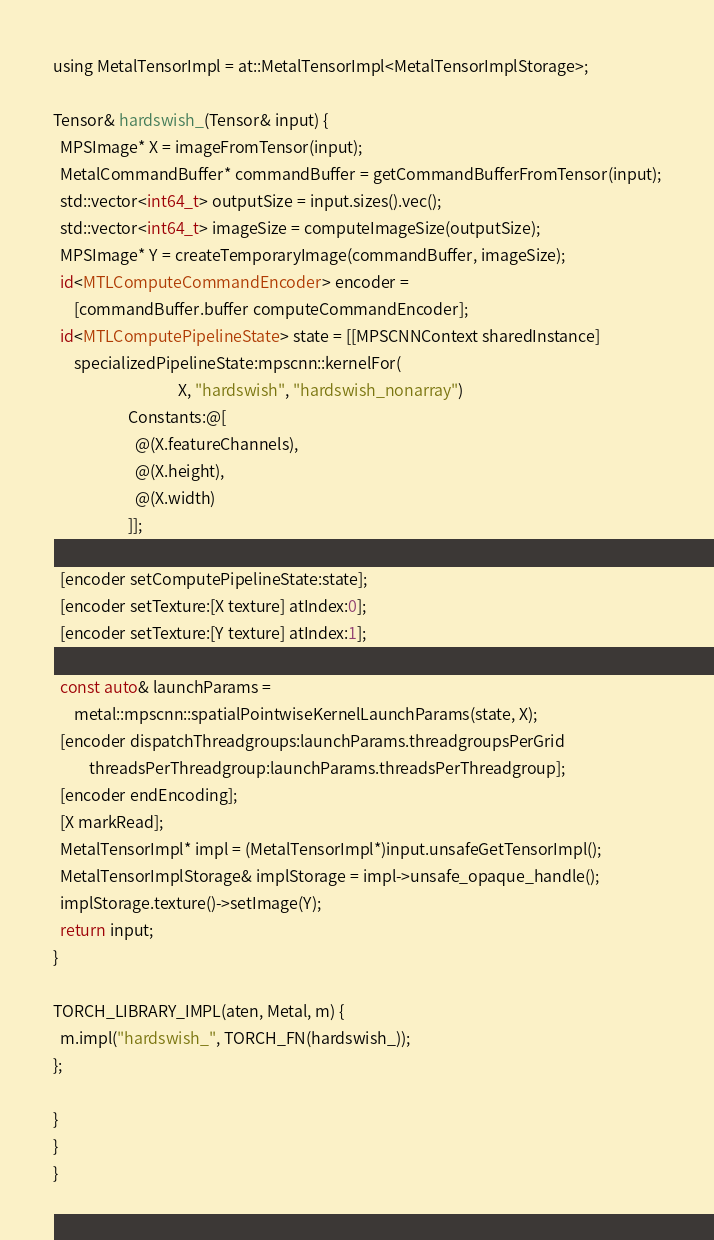Convert code to text. <code><loc_0><loc_0><loc_500><loc_500><_ObjectiveC_>
using MetalTensorImpl = at::MetalTensorImpl<MetalTensorImplStorage>;

Tensor& hardswish_(Tensor& input) {
  MPSImage* X = imageFromTensor(input);
  MetalCommandBuffer* commandBuffer = getCommandBufferFromTensor(input);
  std::vector<int64_t> outputSize = input.sizes().vec();
  std::vector<int64_t> imageSize = computeImageSize(outputSize);
  MPSImage* Y = createTemporaryImage(commandBuffer, imageSize);
  id<MTLComputeCommandEncoder> encoder =
      [commandBuffer.buffer computeCommandEncoder];
  id<MTLComputePipelineState> state = [[MPSCNNContext sharedInstance]
      specializedPipelineState:mpscnn::kernelFor(
                                   X, "hardswish", "hardswish_nonarray")
                     Constants:@[
                       @(X.featureChannels),
                       @(X.height),
                       @(X.width)
                     ]];

  [encoder setComputePipelineState:state];
  [encoder setTexture:[X texture] atIndex:0];
  [encoder setTexture:[Y texture] atIndex:1];

  const auto& launchParams =
      metal::mpscnn::spatialPointwiseKernelLaunchParams(state, X);
  [encoder dispatchThreadgroups:launchParams.threadgroupsPerGrid
          threadsPerThreadgroup:launchParams.threadsPerThreadgroup];
  [encoder endEncoding];
  [X markRead];
  MetalTensorImpl* impl = (MetalTensorImpl*)input.unsafeGetTensorImpl();
  MetalTensorImplStorage& implStorage = impl->unsafe_opaque_handle();
  implStorage.texture()->setImage(Y);
  return input;
}

TORCH_LIBRARY_IMPL(aten, Metal, m) {
  m.impl("hardswish_", TORCH_FN(hardswish_));
};

}
}
}
</code> 